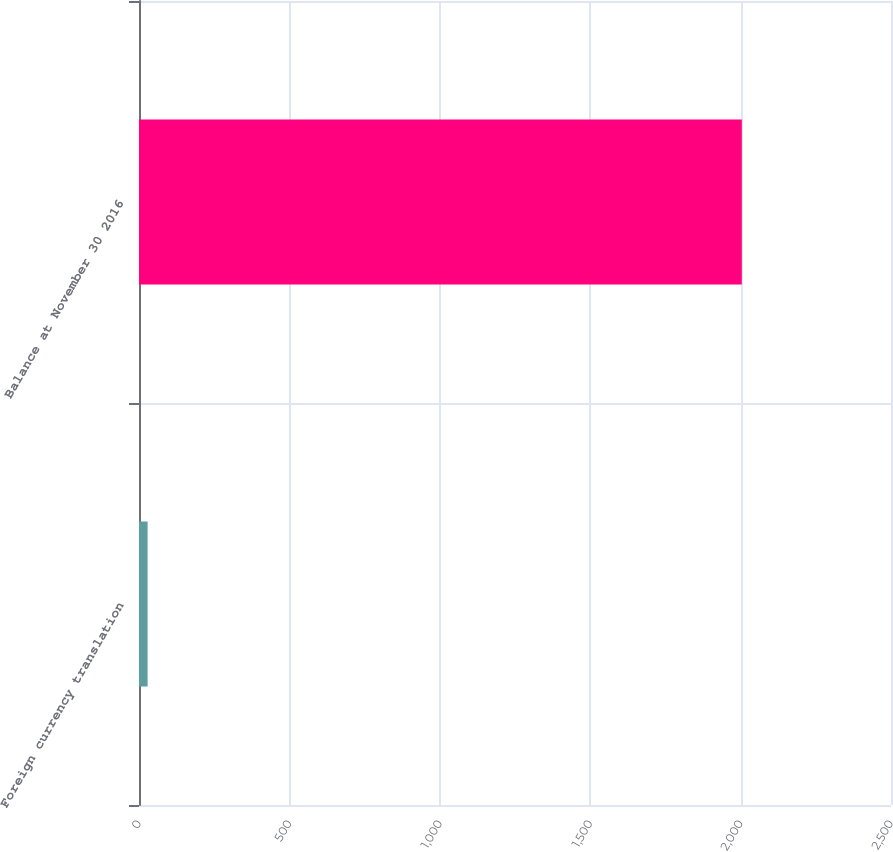<chart> <loc_0><loc_0><loc_500><loc_500><bar_chart><fcel>Foreign currency translation<fcel>Balance at November 30 2016<nl><fcel>28.6<fcel>2004<nl></chart> 